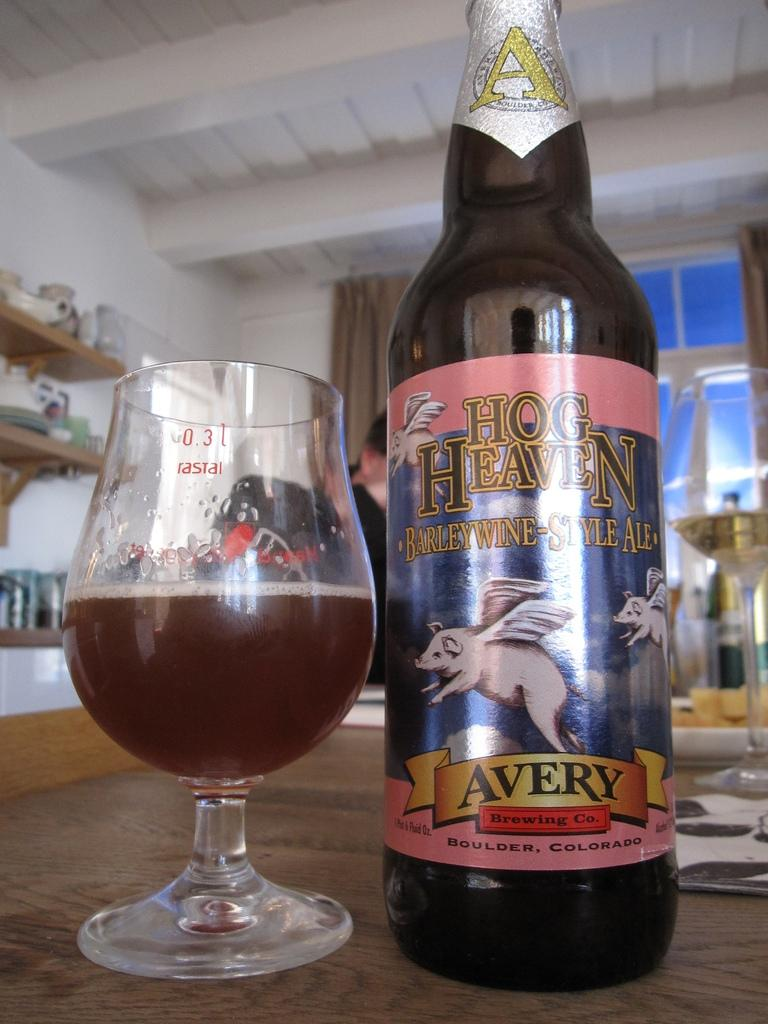Provide a one-sentence caption for the provided image. A bottle of Avery Hog Heaven Barleywine Style Ale sits next to a half full tasting glass. 